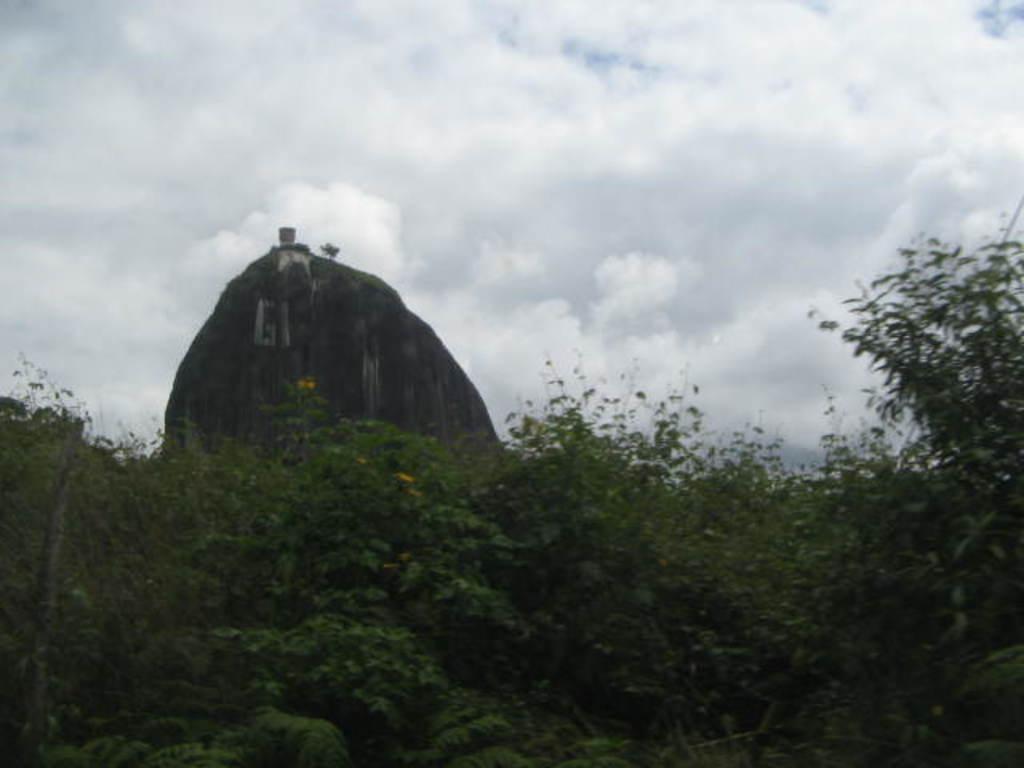Can you describe this image briefly? In the picture I can see plants. In the background I can see the sky and some other objects. 